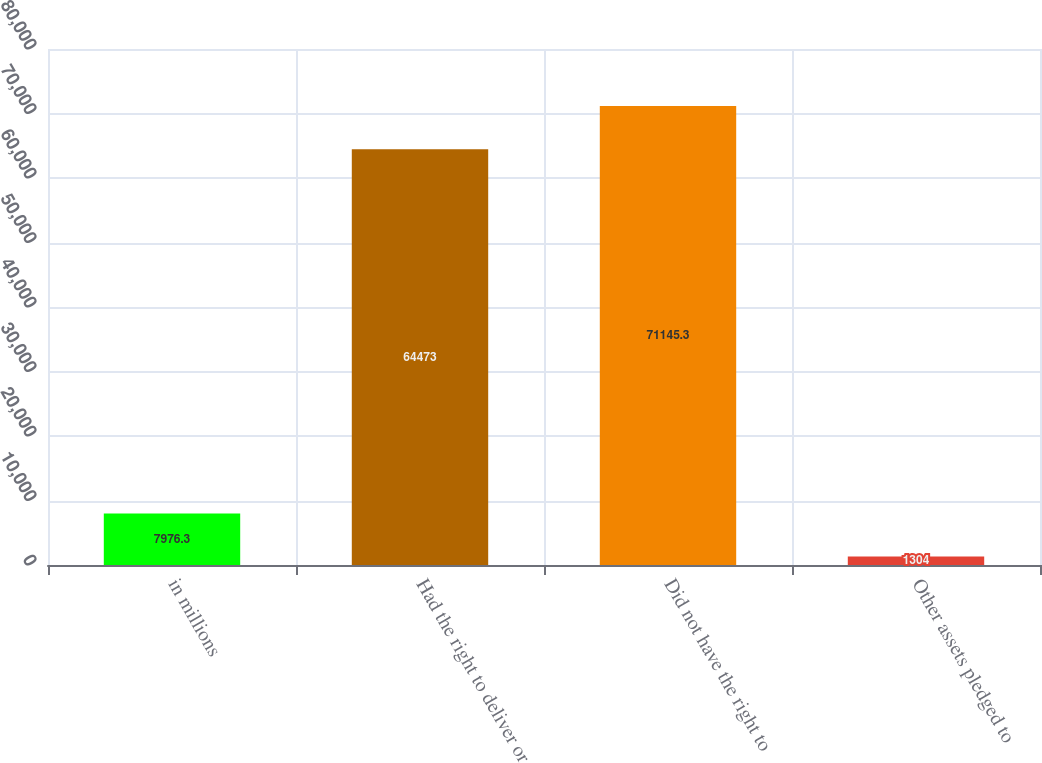<chart> <loc_0><loc_0><loc_500><loc_500><bar_chart><fcel>in millions<fcel>Had the right to deliver or<fcel>Did not have the right to<fcel>Other assets pledged to<nl><fcel>7976.3<fcel>64473<fcel>71145.3<fcel>1304<nl></chart> 